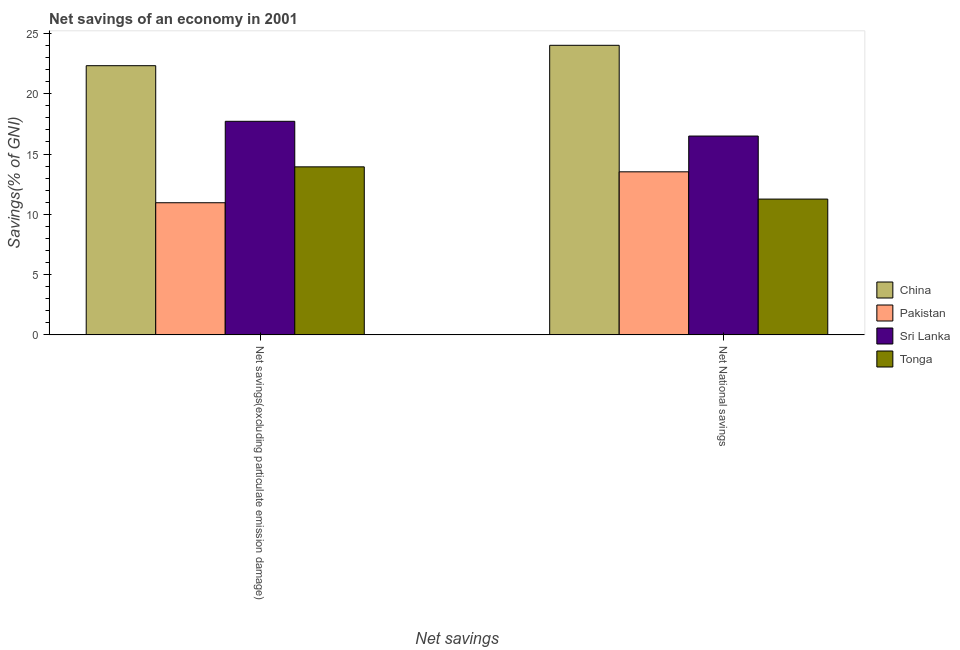How many different coloured bars are there?
Your response must be concise. 4. Are the number of bars per tick equal to the number of legend labels?
Provide a succinct answer. Yes. How many bars are there on the 1st tick from the right?
Keep it short and to the point. 4. What is the label of the 1st group of bars from the left?
Provide a succinct answer. Net savings(excluding particulate emission damage). What is the net savings(excluding particulate emission damage) in Pakistan?
Make the answer very short. 10.96. Across all countries, what is the maximum net national savings?
Your answer should be compact. 24.02. Across all countries, what is the minimum net national savings?
Provide a succinct answer. 11.26. In which country was the net national savings minimum?
Your answer should be very brief. Tonga. What is the total net savings(excluding particulate emission damage) in the graph?
Keep it short and to the point. 64.94. What is the difference between the net national savings in China and that in Pakistan?
Your response must be concise. 10.49. What is the difference between the net national savings in Sri Lanka and the net savings(excluding particulate emission damage) in China?
Your answer should be compact. -5.84. What is the average net savings(excluding particulate emission damage) per country?
Your answer should be compact. 16.23. What is the difference between the net national savings and net savings(excluding particulate emission damage) in Pakistan?
Your response must be concise. 2.56. In how many countries, is the net national savings greater than 15 %?
Provide a short and direct response. 2. What is the ratio of the net savings(excluding particulate emission damage) in China to that in Tonga?
Give a very brief answer. 1.6. Is the net national savings in China less than that in Pakistan?
Give a very brief answer. No. In how many countries, is the net savings(excluding particulate emission damage) greater than the average net savings(excluding particulate emission damage) taken over all countries?
Offer a terse response. 2. What does the 2nd bar from the right in Net savings(excluding particulate emission damage) represents?
Make the answer very short. Sri Lanka. How many countries are there in the graph?
Your answer should be compact. 4. Does the graph contain any zero values?
Offer a very short reply. No. Does the graph contain grids?
Provide a short and direct response. No. Where does the legend appear in the graph?
Provide a short and direct response. Center right. How many legend labels are there?
Offer a very short reply. 4. What is the title of the graph?
Make the answer very short. Net savings of an economy in 2001. What is the label or title of the X-axis?
Provide a short and direct response. Net savings. What is the label or title of the Y-axis?
Keep it short and to the point. Savings(% of GNI). What is the Savings(% of GNI) of China in Net savings(excluding particulate emission damage)?
Your answer should be compact. 22.33. What is the Savings(% of GNI) in Pakistan in Net savings(excluding particulate emission damage)?
Your answer should be very brief. 10.96. What is the Savings(% of GNI) in Sri Lanka in Net savings(excluding particulate emission damage)?
Ensure brevity in your answer.  17.71. What is the Savings(% of GNI) of Tonga in Net savings(excluding particulate emission damage)?
Your answer should be very brief. 13.94. What is the Savings(% of GNI) of China in Net National savings?
Give a very brief answer. 24.02. What is the Savings(% of GNI) of Pakistan in Net National savings?
Your answer should be very brief. 13.52. What is the Savings(% of GNI) of Sri Lanka in Net National savings?
Your response must be concise. 16.49. What is the Savings(% of GNI) of Tonga in Net National savings?
Your answer should be compact. 11.26. Across all Net savings, what is the maximum Savings(% of GNI) in China?
Offer a terse response. 24.02. Across all Net savings, what is the maximum Savings(% of GNI) in Pakistan?
Keep it short and to the point. 13.52. Across all Net savings, what is the maximum Savings(% of GNI) of Sri Lanka?
Make the answer very short. 17.71. Across all Net savings, what is the maximum Savings(% of GNI) of Tonga?
Make the answer very short. 13.94. Across all Net savings, what is the minimum Savings(% of GNI) in China?
Your response must be concise. 22.33. Across all Net savings, what is the minimum Savings(% of GNI) of Pakistan?
Ensure brevity in your answer.  10.96. Across all Net savings, what is the minimum Savings(% of GNI) in Sri Lanka?
Keep it short and to the point. 16.49. Across all Net savings, what is the minimum Savings(% of GNI) in Tonga?
Make the answer very short. 11.26. What is the total Savings(% of GNI) of China in the graph?
Your answer should be very brief. 46.34. What is the total Savings(% of GNI) in Pakistan in the graph?
Your answer should be compact. 24.48. What is the total Savings(% of GNI) in Sri Lanka in the graph?
Make the answer very short. 34.2. What is the total Savings(% of GNI) of Tonga in the graph?
Your response must be concise. 25.2. What is the difference between the Savings(% of GNI) in China in Net savings(excluding particulate emission damage) and that in Net National savings?
Offer a terse response. -1.69. What is the difference between the Savings(% of GNI) of Pakistan in Net savings(excluding particulate emission damage) and that in Net National savings?
Give a very brief answer. -2.56. What is the difference between the Savings(% of GNI) in Sri Lanka in Net savings(excluding particulate emission damage) and that in Net National savings?
Provide a succinct answer. 1.22. What is the difference between the Savings(% of GNI) in Tonga in Net savings(excluding particulate emission damage) and that in Net National savings?
Offer a very short reply. 2.67. What is the difference between the Savings(% of GNI) of China in Net savings(excluding particulate emission damage) and the Savings(% of GNI) of Pakistan in Net National savings?
Provide a short and direct response. 8.8. What is the difference between the Savings(% of GNI) of China in Net savings(excluding particulate emission damage) and the Savings(% of GNI) of Sri Lanka in Net National savings?
Provide a succinct answer. 5.84. What is the difference between the Savings(% of GNI) of China in Net savings(excluding particulate emission damage) and the Savings(% of GNI) of Tonga in Net National savings?
Offer a very short reply. 11.06. What is the difference between the Savings(% of GNI) of Pakistan in Net savings(excluding particulate emission damage) and the Savings(% of GNI) of Sri Lanka in Net National savings?
Your answer should be compact. -5.53. What is the difference between the Savings(% of GNI) of Pakistan in Net savings(excluding particulate emission damage) and the Savings(% of GNI) of Tonga in Net National savings?
Provide a short and direct response. -0.3. What is the difference between the Savings(% of GNI) of Sri Lanka in Net savings(excluding particulate emission damage) and the Savings(% of GNI) of Tonga in Net National savings?
Give a very brief answer. 6.45. What is the average Savings(% of GNI) in China per Net savings?
Offer a very short reply. 23.17. What is the average Savings(% of GNI) in Pakistan per Net savings?
Offer a terse response. 12.24. What is the average Savings(% of GNI) in Sri Lanka per Net savings?
Make the answer very short. 17.1. What is the average Savings(% of GNI) in Tonga per Net savings?
Provide a short and direct response. 12.6. What is the difference between the Savings(% of GNI) of China and Savings(% of GNI) of Pakistan in Net savings(excluding particulate emission damage)?
Your response must be concise. 11.37. What is the difference between the Savings(% of GNI) in China and Savings(% of GNI) in Sri Lanka in Net savings(excluding particulate emission damage)?
Provide a succinct answer. 4.61. What is the difference between the Savings(% of GNI) of China and Savings(% of GNI) of Tonga in Net savings(excluding particulate emission damage)?
Ensure brevity in your answer.  8.39. What is the difference between the Savings(% of GNI) of Pakistan and Savings(% of GNI) of Sri Lanka in Net savings(excluding particulate emission damage)?
Keep it short and to the point. -6.75. What is the difference between the Savings(% of GNI) in Pakistan and Savings(% of GNI) in Tonga in Net savings(excluding particulate emission damage)?
Offer a terse response. -2.98. What is the difference between the Savings(% of GNI) in Sri Lanka and Savings(% of GNI) in Tonga in Net savings(excluding particulate emission damage)?
Your response must be concise. 3.78. What is the difference between the Savings(% of GNI) in China and Savings(% of GNI) in Pakistan in Net National savings?
Offer a very short reply. 10.49. What is the difference between the Savings(% of GNI) of China and Savings(% of GNI) of Sri Lanka in Net National savings?
Provide a succinct answer. 7.53. What is the difference between the Savings(% of GNI) of China and Savings(% of GNI) of Tonga in Net National savings?
Your answer should be very brief. 12.75. What is the difference between the Savings(% of GNI) in Pakistan and Savings(% of GNI) in Sri Lanka in Net National savings?
Keep it short and to the point. -2.97. What is the difference between the Savings(% of GNI) of Pakistan and Savings(% of GNI) of Tonga in Net National savings?
Make the answer very short. 2.26. What is the difference between the Savings(% of GNI) in Sri Lanka and Savings(% of GNI) in Tonga in Net National savings?
Offer a terse response. 5.23. What is the ratio of the Savings(% of GNI) of China in Net savings(excluding particulate emission damage) to that in Net National savings?
Your response must be concise. 0.93. What is the ratio of the Savings(% of GNI) of Pakistan in Net savings(excluding particulate emission damage) to that in Net National savings?
Your answer should be very brief. 0.81. What is the ratio of the Savings(% of GNI) of Sri Lanka in Net savings(excluding particulate emission damage) to that in Net National savings?
Offer a very short reply. 1.07. What is the ratio of the Savings(% of GNI) in Tonga in Net savings(excluding particulate emission damage) to that in Net National savings?
Your answer should be very brief. 1.24. What is the difference between the highest and the second highest Savings(% of GNI) in China?
Ensure brevity in your answer.  1.69. What is the difference between the highest and the second highest Savings(% of GNI) in Pakistan?
Your answer should be very brief. 2.56. What is the difference between the highest and the second highest Savings(% of GNI) of Sri Lanka?
Make the answer very short. 1.22. What is the difference between the highest and the second highest Savings(% of GNI) of Tonga?
Offer a terse response. 2.67. What is the difference between the highest and the lowest Savings(% of GNI) of China?
Offer a very short reply. 1.69. What is the difference between the highest and the lowest Savings(% of GNI) in Pakistan?
Your answer should be compact. 2.56. What is the difference between the highest and the lowest Savings(% of GNI) in Sri Lanka?
Provide a succinct answer. 1.22. What is the difference between the highest and the lowest Savings(% of GNI) in Tonga?
Your response must be concise. 2.67. 